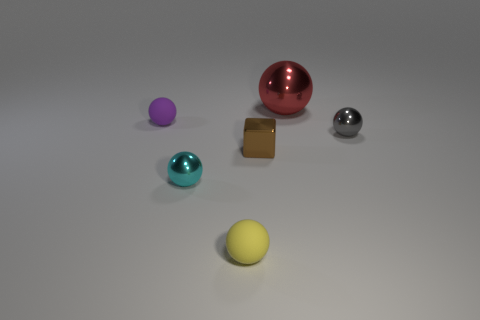Subtract all tiny cyan spheres. How many spheres are left? 4 Add 1 large purple spheres. How many objects exist? 7 Subtract all cyan spheres. How many spheres are left? 4 Subtract all balls. How many objects are left? 1 Subtract 2 balls. How many balls are left? 3 Add 3 tiny cyan metallic things. How many tiny cyan metallic things are left? 4 Add 6 red metallic spheres. How many red metallic spheres exist? 7 Subtract 1 cyan spheres. How many objects are left? 5 Subtract all purple balls. Subtract all blue blocks. How many balls are left? 4 Subtract all yellow things. Subtract all small purple balls. How many objects are left? 4 